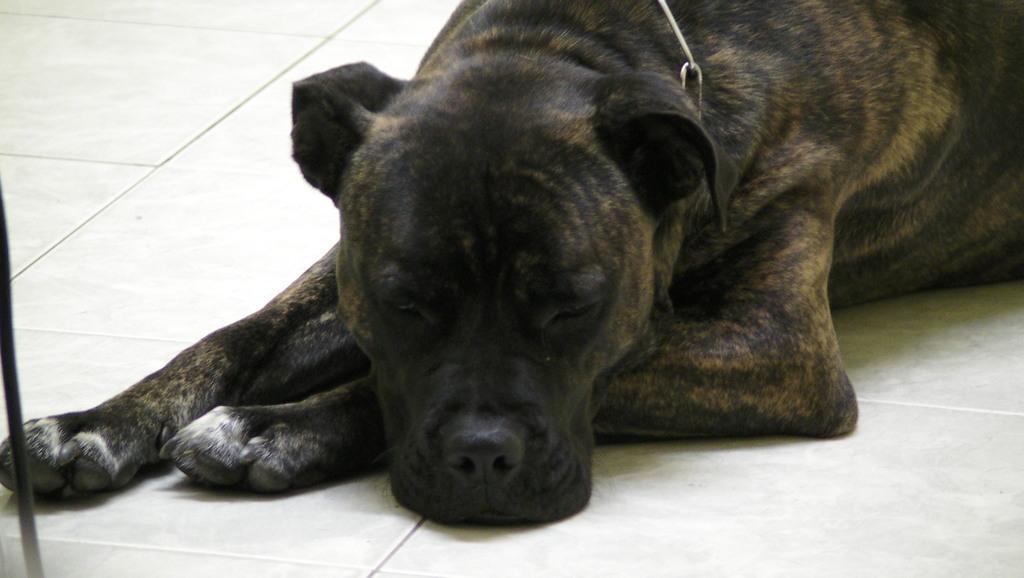Could you give a brief overview of what you see in this image? In the center of the image there is a dog on the floor. 